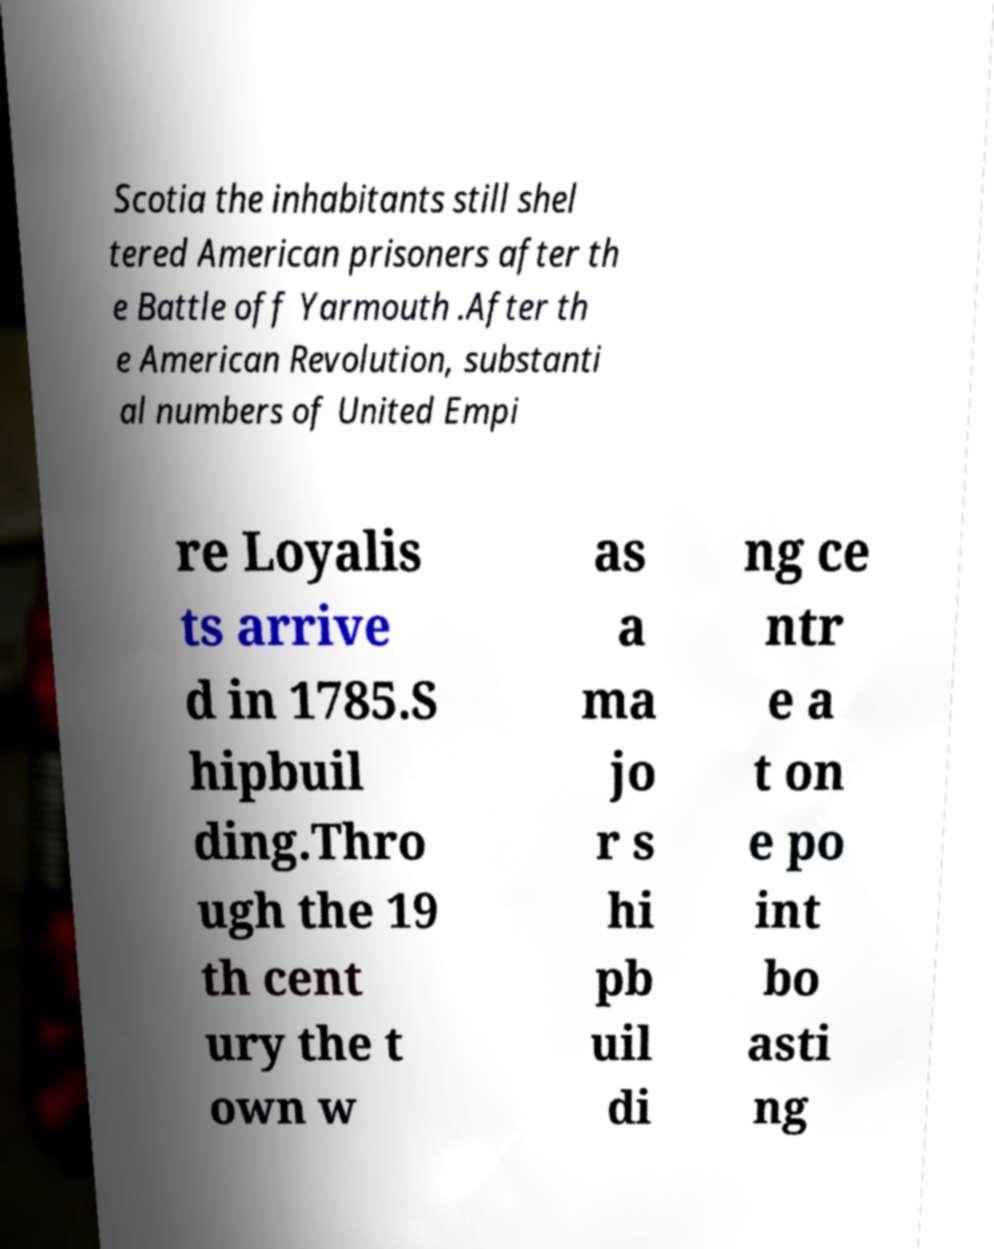Please identify and transcribe the text found in this image. Scotia the inhabitants still shel tered American prisoners after th e Battle off Yarmouth .After th e American Revolution, substanti al numbers of United Empi re Loyalis ts arrive d in 1785.S hipbuil ding.Thro ugh the 19 th cent ury the t own w as a ma jo r s hi pb uil di ng ce ntr e a t on e po int bo asti ng 